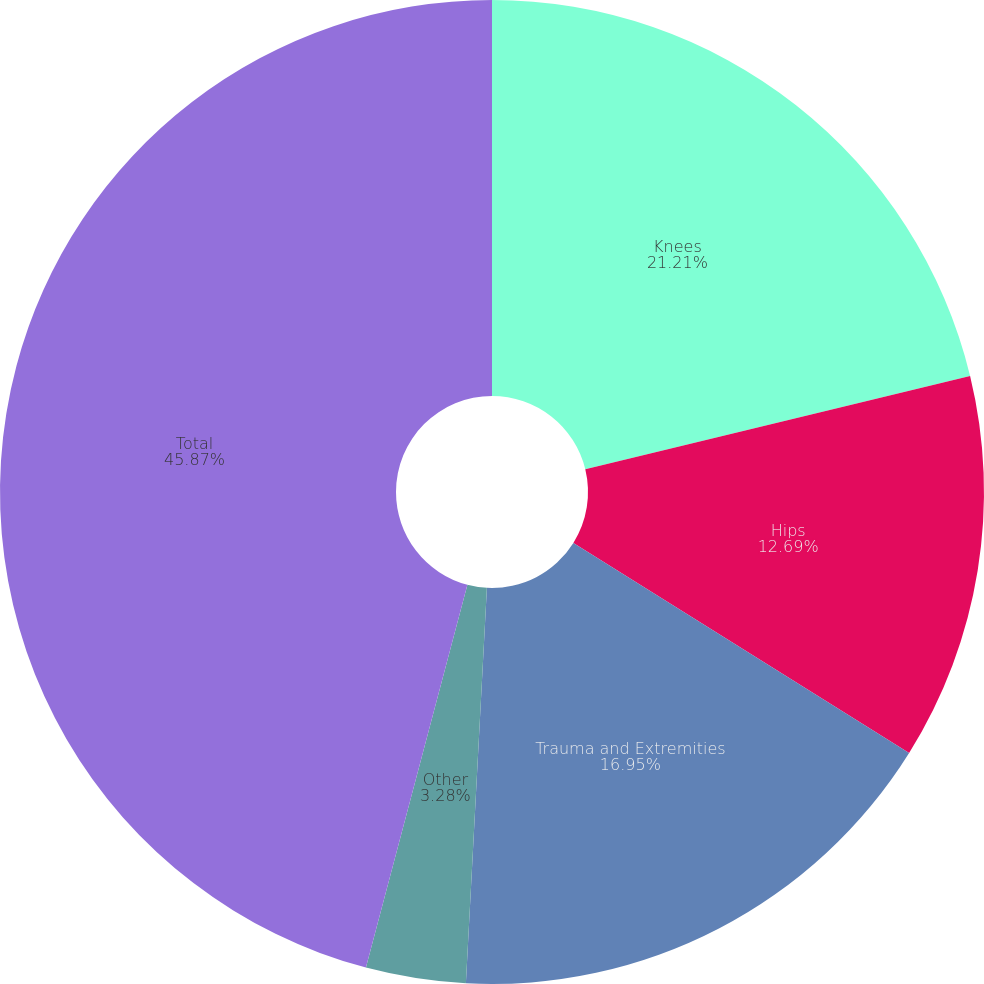Convert chart. <chart><loc_0><loc_0><loc_500><loc_500><pie_chart><fcel>Knees<fcel>Hips<fcel>Trauma and Extremities<fcel>Other<fcel>Total<nl><fcel>21.21%<fcel>12.69%<fcel>16.95%<fcel>3.28%<fcel>45.88%<nl></chart> 